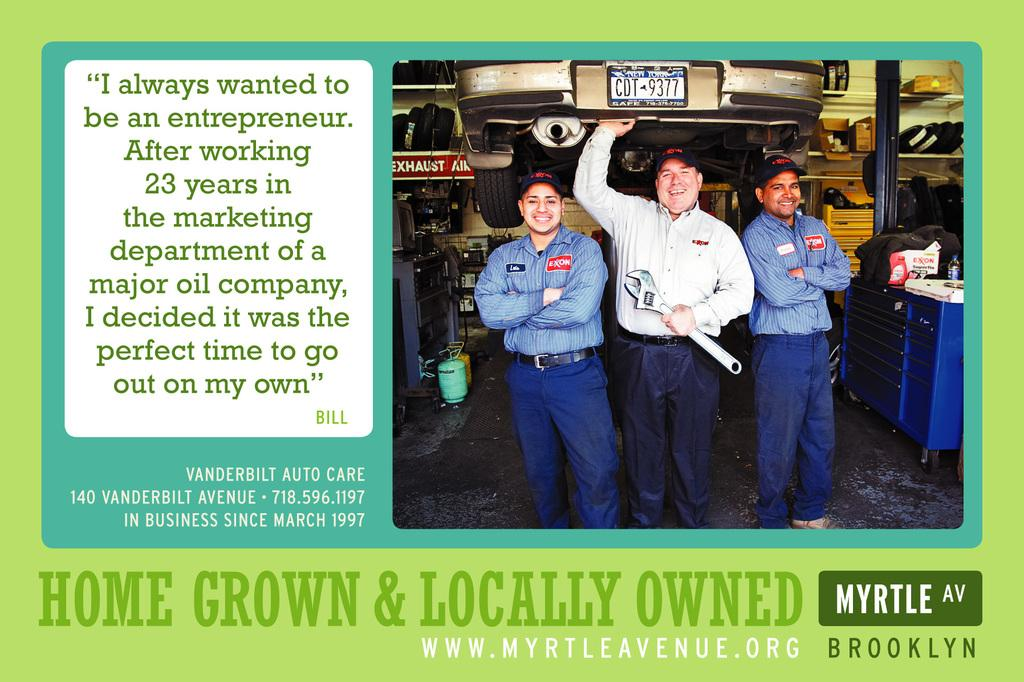What is the main subject of the image? The main subject of the image is an advertisement. What types of products are featured in the advertisement? The advertisement contains pictures of cardboard cartons, motor vehicles, spare parts, persons standing on the floor, and bags. What sense of humor does the advertisement convey? The image does not provide any information about the sense of humor conveyed by the advertisement. --- Facts: 1. There is a person sitting on a chair in the image. 2. The person is holding a book. 3. The book has a blue cover. 4. The person is wearing glasses. 5. There is a table next to the chair. Absurd Topics: dance, ocean, instrument Conversation: What is the person in the image doing? The person in the image is sitting on a chair. What is the person holding in the image? The person is holding a book. What color is the book's cover? The book has a blue cover. What accessory is the person wearing? The person is wearing glasses. What is located next to the chair in the image? There is a table next to the chair. Reasoning: Let's think step by step in order to produce the conversation. We start by identifying the main subject of the image, which is the person sitting on a chair. Then, we describe the various objects and elements that are associated with the person, such as the book, its blue cover, the glasses, and the table. Each question is designed to elicit a specific detail about the image that is known from the provided facts. Absurd Question/Answer: What type of dance is the person performing in the image? There is no indication in the image that the person is dancing, as they are sitting on a chair and holding a book. 